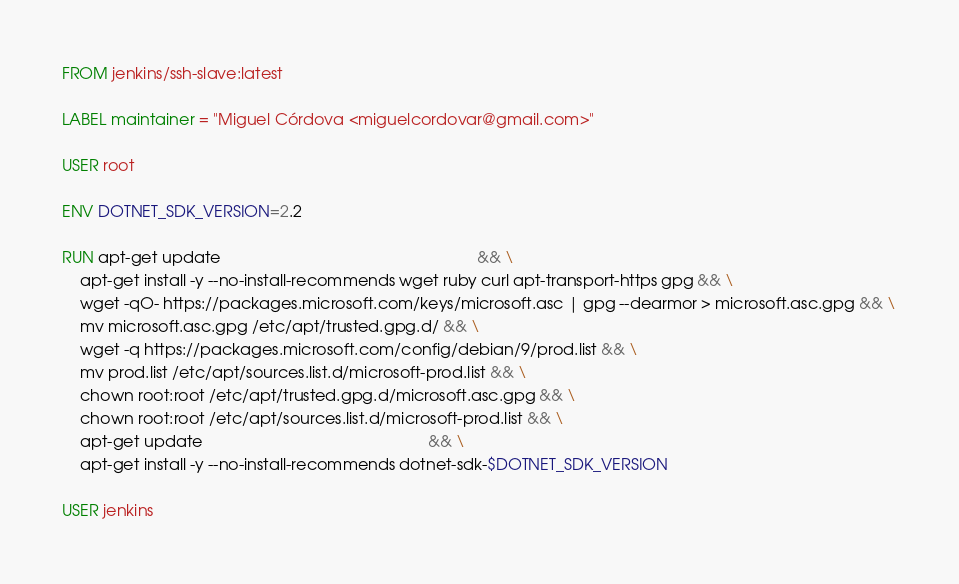<code> <loc_0><loc_0><loc_500><loc_500><_Dockerfile_>FROM jenkins/ssh-slave:latest

LABEL maintainer = "Miguel Córdova <miguelcordovar@gmail.com>"

USER root

ENV DOTNET_SDK_VERSION=2.2

RUN apt-get update                                                          && \
    apt-get install -y --no-install-recommends wget ruby curl apt-transport-https gpg && \
    wget -qO- https://packages.microsoft.com/keys/microsoft.asc | gpg --dearmor > microsoft.asc.gpg && \
    mv microsoft.asc.gpg /etc/apt/trusted.gpg.d/ && \
    wget -q https://packages.microsoft.com/config/debian/9/prod.list && \
    mv prod.list /etc/apt/sources.list.d/microsoft-prod.list && \
    chown root:root /etc/apt/trusted.gpg.d/microsoft.asc.gpg && \
    chown root:root /etc/apt/sources.list.d/microsoft-prod.list && \
    apt-get update                                                   && \
    apt-get install -y --no-install-recommends dotnet-sdk-$DOTNET_SDK_VERSION

USER jenkins</code> 